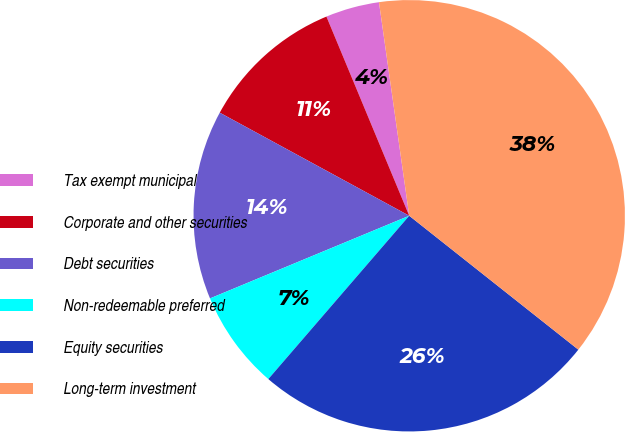Convert chart to OTSL. <chart><loc_0><loc_0><loc_500><loc_500><pie_chart><fcel>Tax exempt municipal<fcel>Corporate and other securities<fcel>Debt securities<fcel>Non-redeemable preferred<fcel>Equity securities<fcel>Long-term investment<nl><fcel>4.03%<fcel>10.8%<fcel>14.19%<fcel>7.41%<fcel>25.67%<fcel>37.9%<nl></chart> 